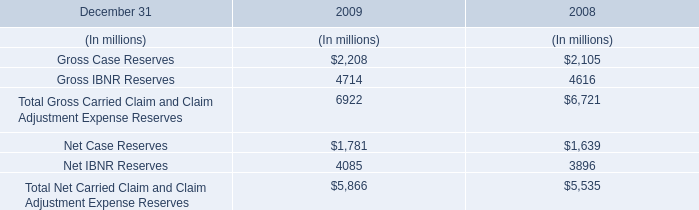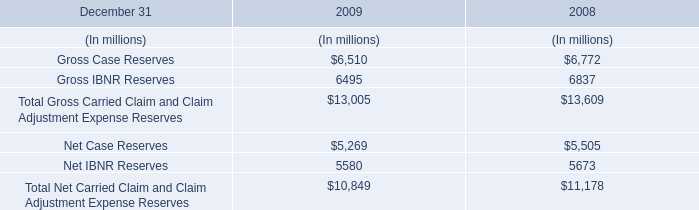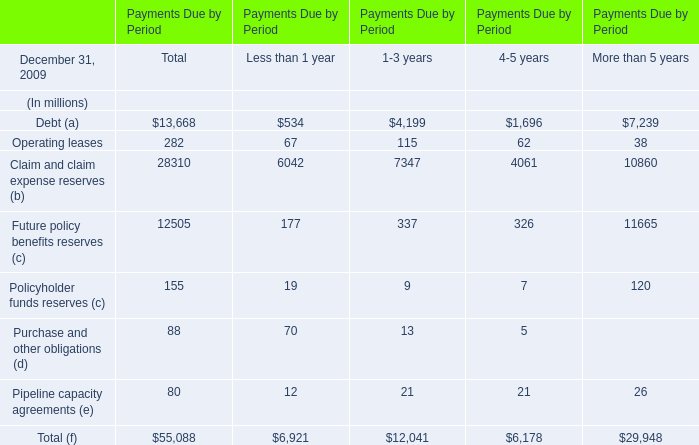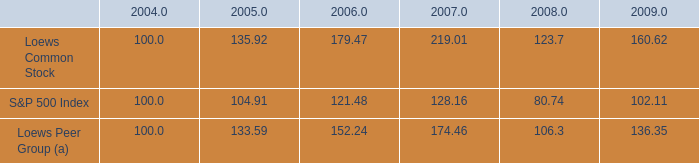What is the sum of the Future policy benefits reserves (c) in the year where Operating leases greater than 65 ? (in million) 
Computations: (((177 + 337) + 326) + 11665)
Answer: 12505.0. 